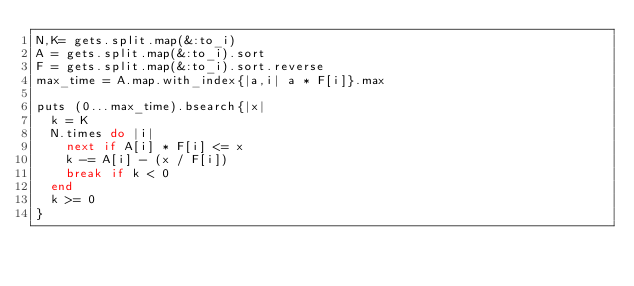<code> <loc_0><loc_0><loc_500><loc_500><_Ruby_>N,K= gets.split.map(&:to_i)
A = gets.split.map(&:to_i).sort
F = gets.split.map(&:to_i).sort.reverse
max_time = A.map.with_index{|a,i| a * F[i]}.max

puts (0...max_time).bsearch{|x|
  k = K
  N.times do |i|
    next if A[i] * F[i] <= x
    k -= A[i] - (x / F[i])
    break if k < 0
  end
  k >= 0
}</code> 